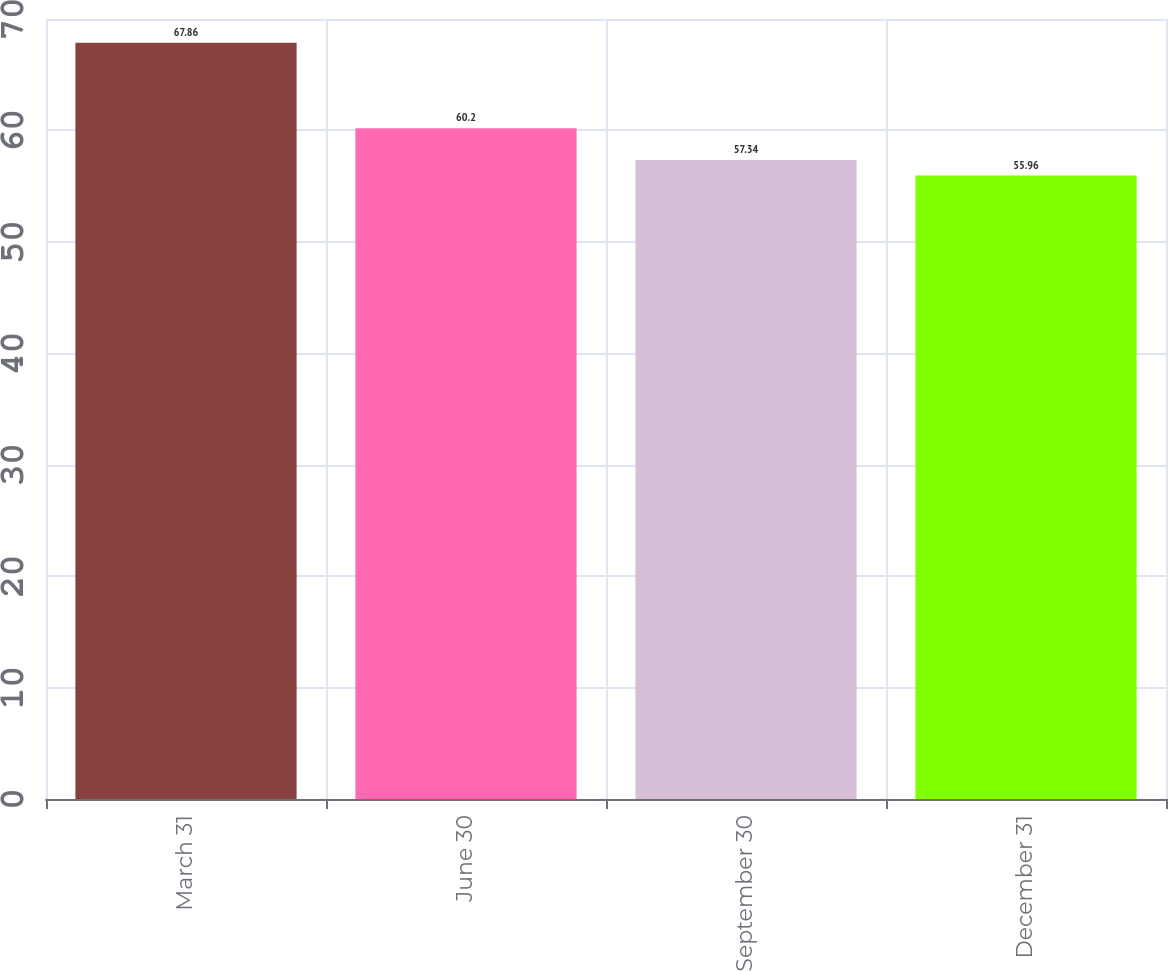<chart> <loc_0><loc_0><loc_500><loc_500><bar_chart><fcel>March 31<fcel>June 30<fcel>September 30<fcel>December 31<nl><fcel>67.86<fcel>60.2<fcel>57.34<fcel>55.96<nl></chart> 